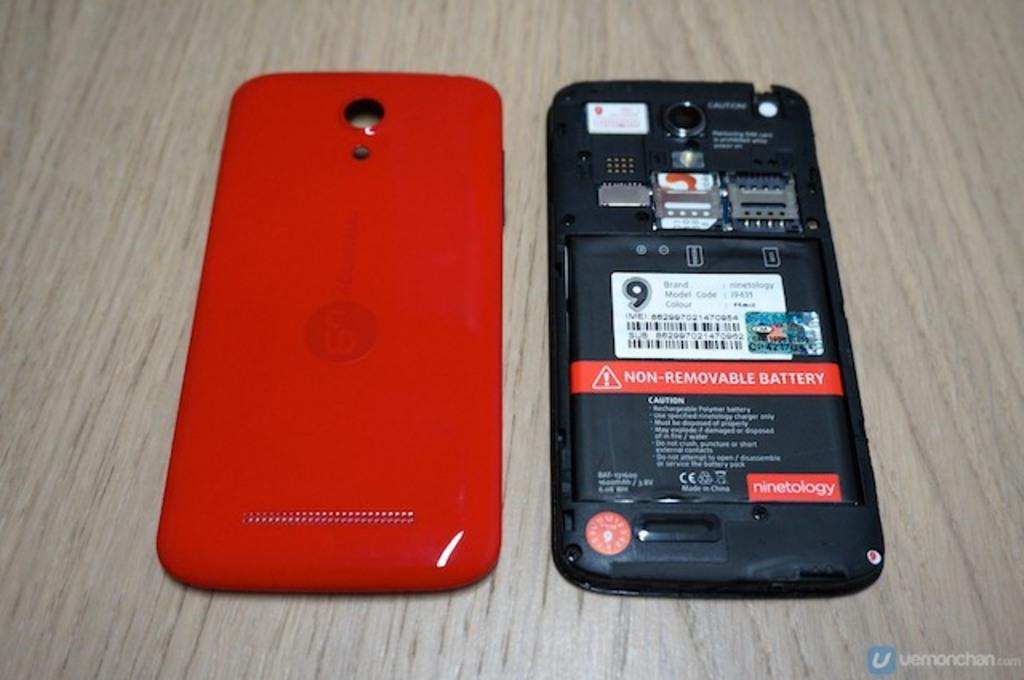<image>
Offer a succinct explanation of the picture presented. A red smart phone with the cover removed to show the non-removable battery. 